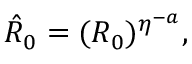Convert formula to latex. <formula><loc_0><loc_0><loc_500><loc_500>\begin{array} { r } { \hat { R } _ { 0 } = ( R _ { 0 } ) ^ { \eta ^ { - a } } , } \end{array}</formula> 